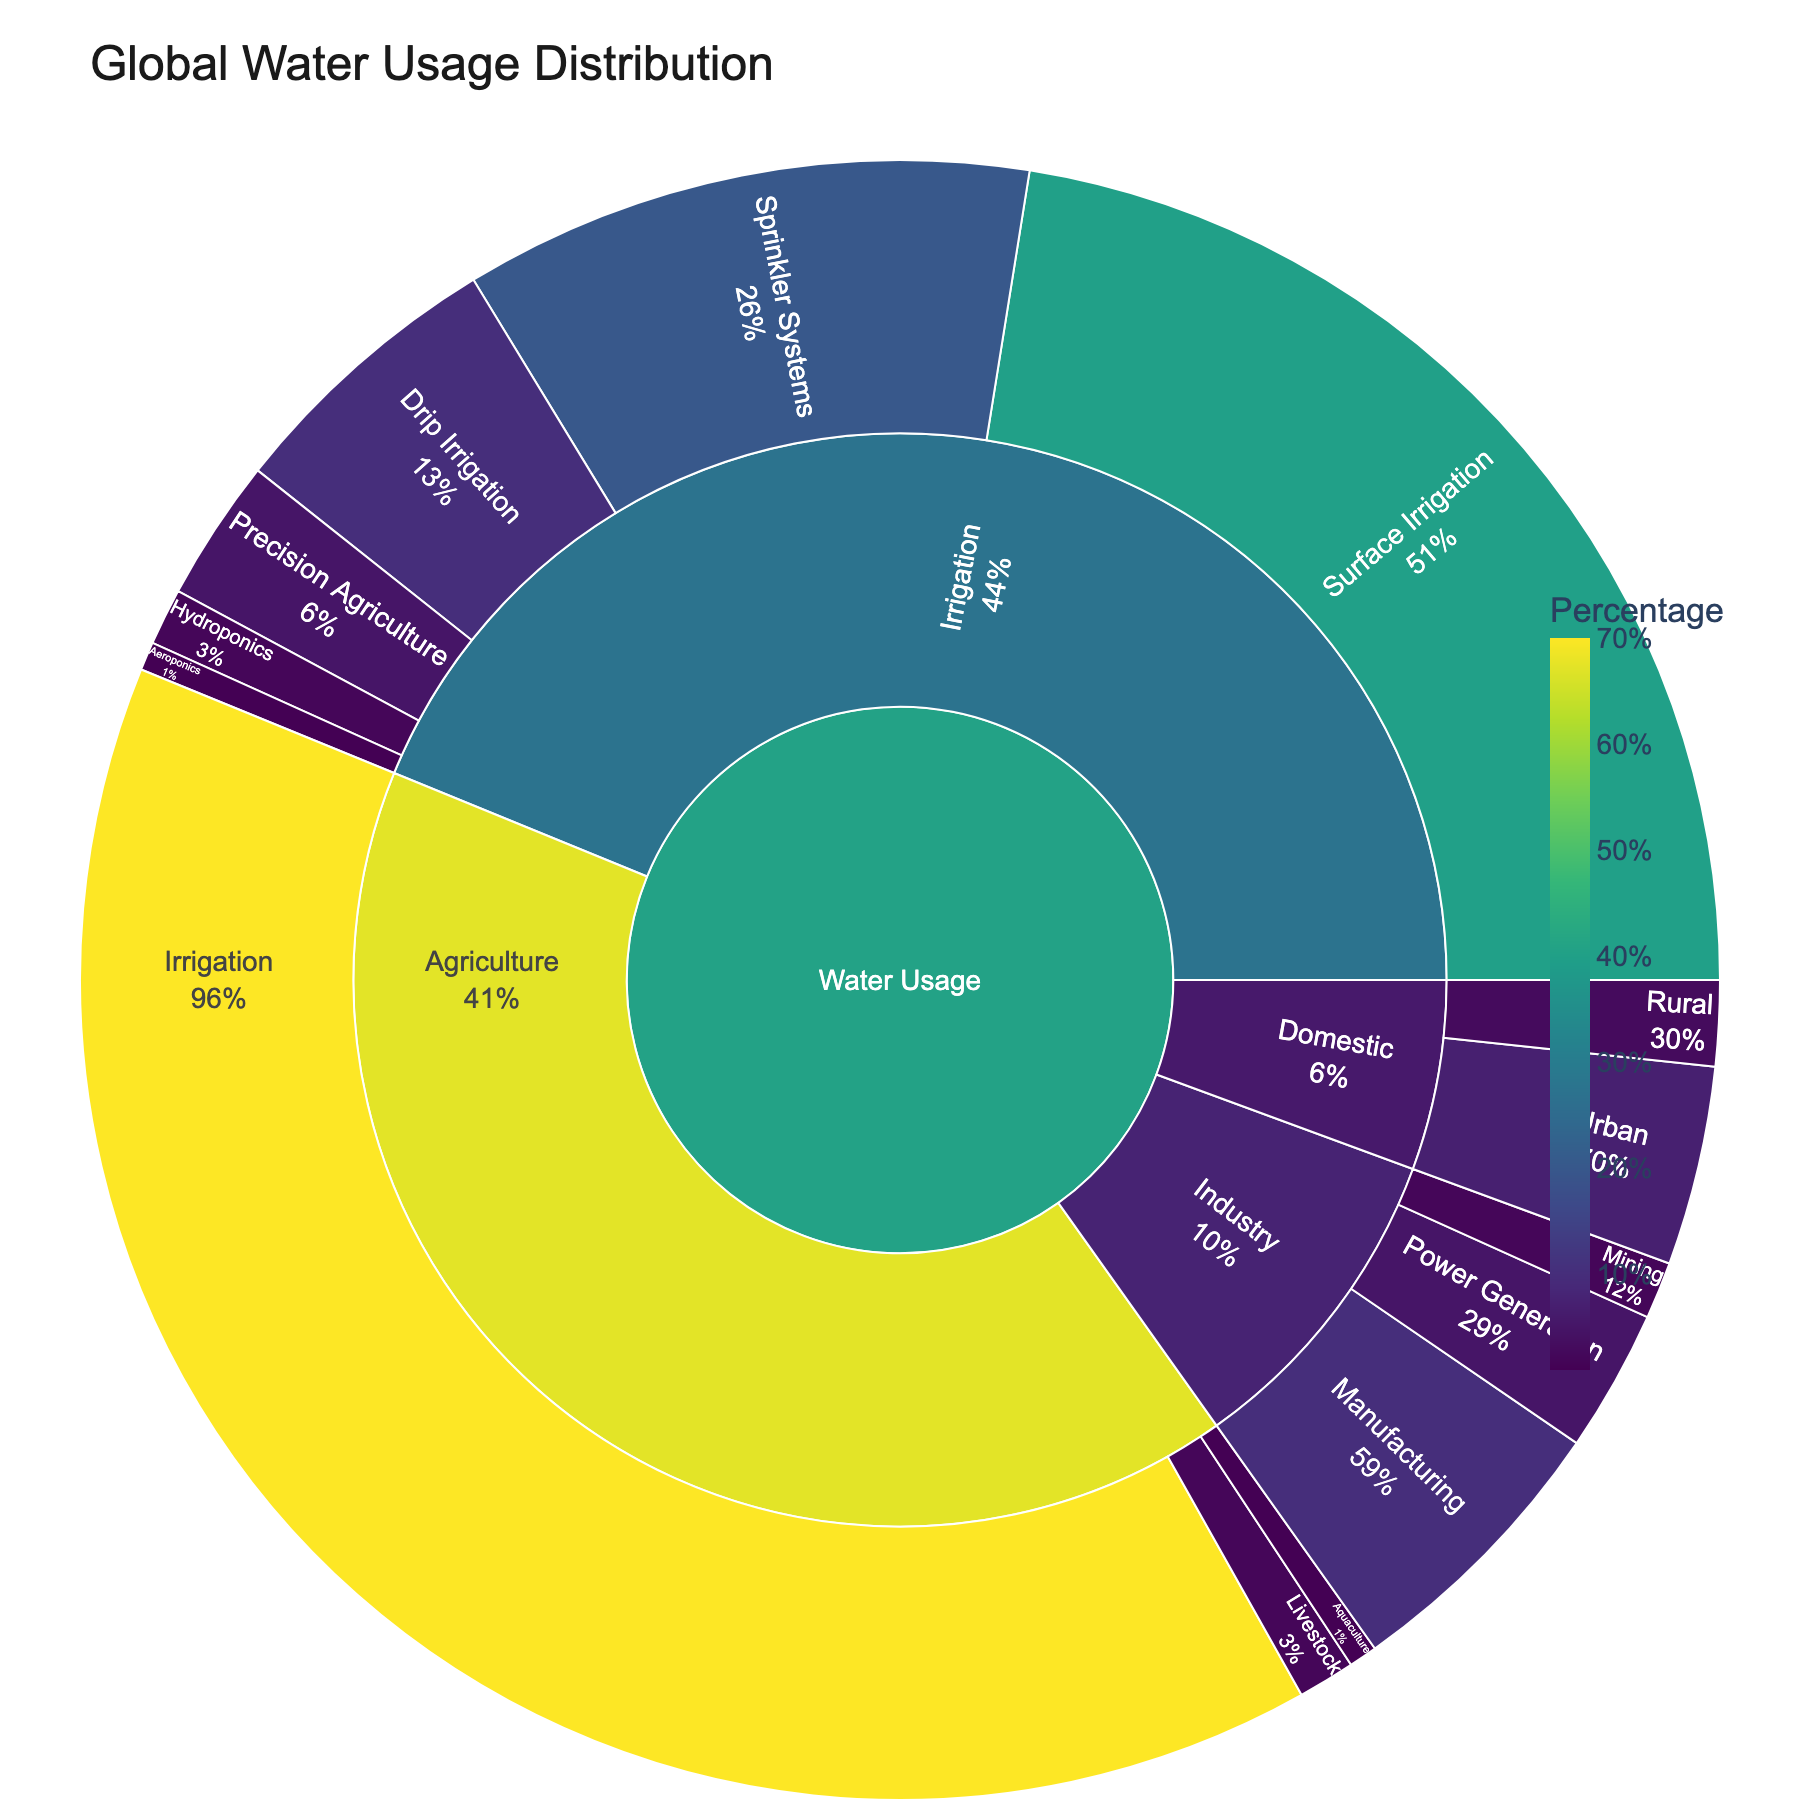What is the title of the plot? The title is typically found at the top of the plot, often in a larger or bold font for emphasis. In this plot, it reads "Global Water Usage Distribution".
Answer: Global Water Usage Distribution Which subsector within the Agriculture sector uses the most water? By examining the subsectors under Agriculture, it's evident that Irrigation has the highest water usage, represented by the largest portion.
Answer: Irrigation What is the total percentage of water used for industry-related purposes? The Industry sector is divided into categories: Manufacturing, Power Generation, and Mining. Adding their percentages provides the total: 10% + 5% + 2% = 17%.
Answer: 17% Which type of irrigation method uses the least amount of water? By analyzing the categories within the Irrigation subsector, Aeroponics stands out as the method with the smallest percentage.
Answer: Aeroponics How does urban domestic water usage compare to rural domestic water usage? Urban domestic water usage is shown as 7%, whereas rural domestic water usage is 3%. Urban usage is more than double the rural usage.
Answer: Urban usage is more What is the combined water usage percentage for agriculture and domestic sectors? To find this, add the total percentages from Agriculture (70% + 2% + 1% = 73%) and Domestic (7% + 3% = 10%): 73% + 10% = 83%.
Answer: 83% How does the percentage of water used for drip irrigation compare to sprinkler systems? Drip irrigation uses 10%, while sprinkler systems use 20%. So, sprinkler systems use double the amount of water compared to drip irrigation.
Answer: Sprinkler systems use more Which segment in the plot uses the most water overall? Observing the global context, the largest segment belongs to Agriculture, specifically Irrigation within it, which stands out as the highest at 70%.
Answer: Irrigation How many irrigation categories are displayed in the plot, and what are they? The sunburst plot shows the Irrigation subsector divided into 6 categories: Surface Irrigation, Sprinkler Systems, Drip Irrigation, Precision Agriculture, Hydroponics, and Aeroponics.
Answer: 6 categories: Surface Irrigation, Sprinkler Systems, Drip Irrigation, Precision Agriculture, Hydroponics, Aeroponics 